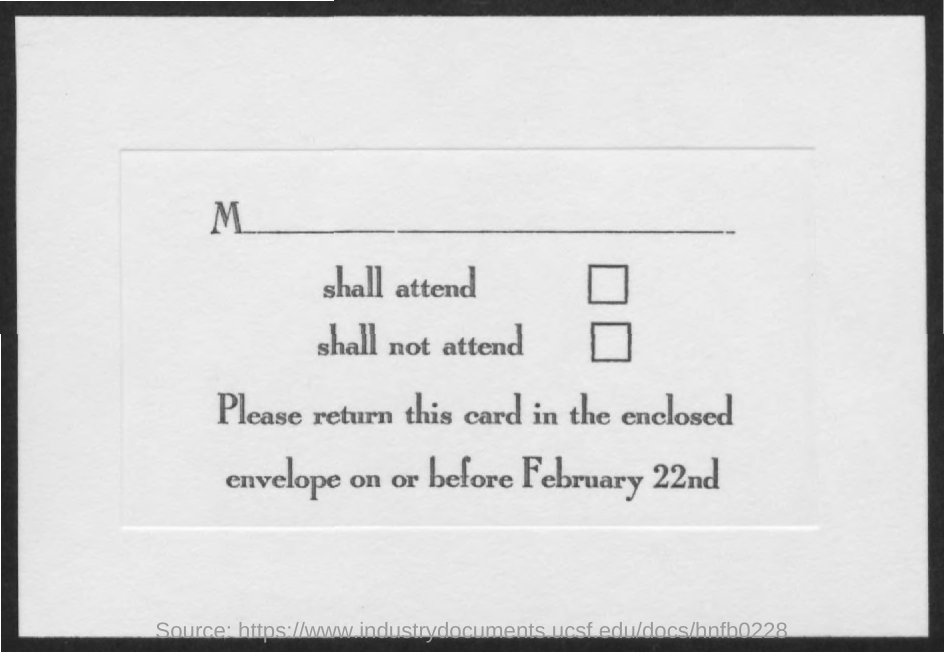Indicate a few pertinent items in this graphic. The card should be returned by February 22nd. 